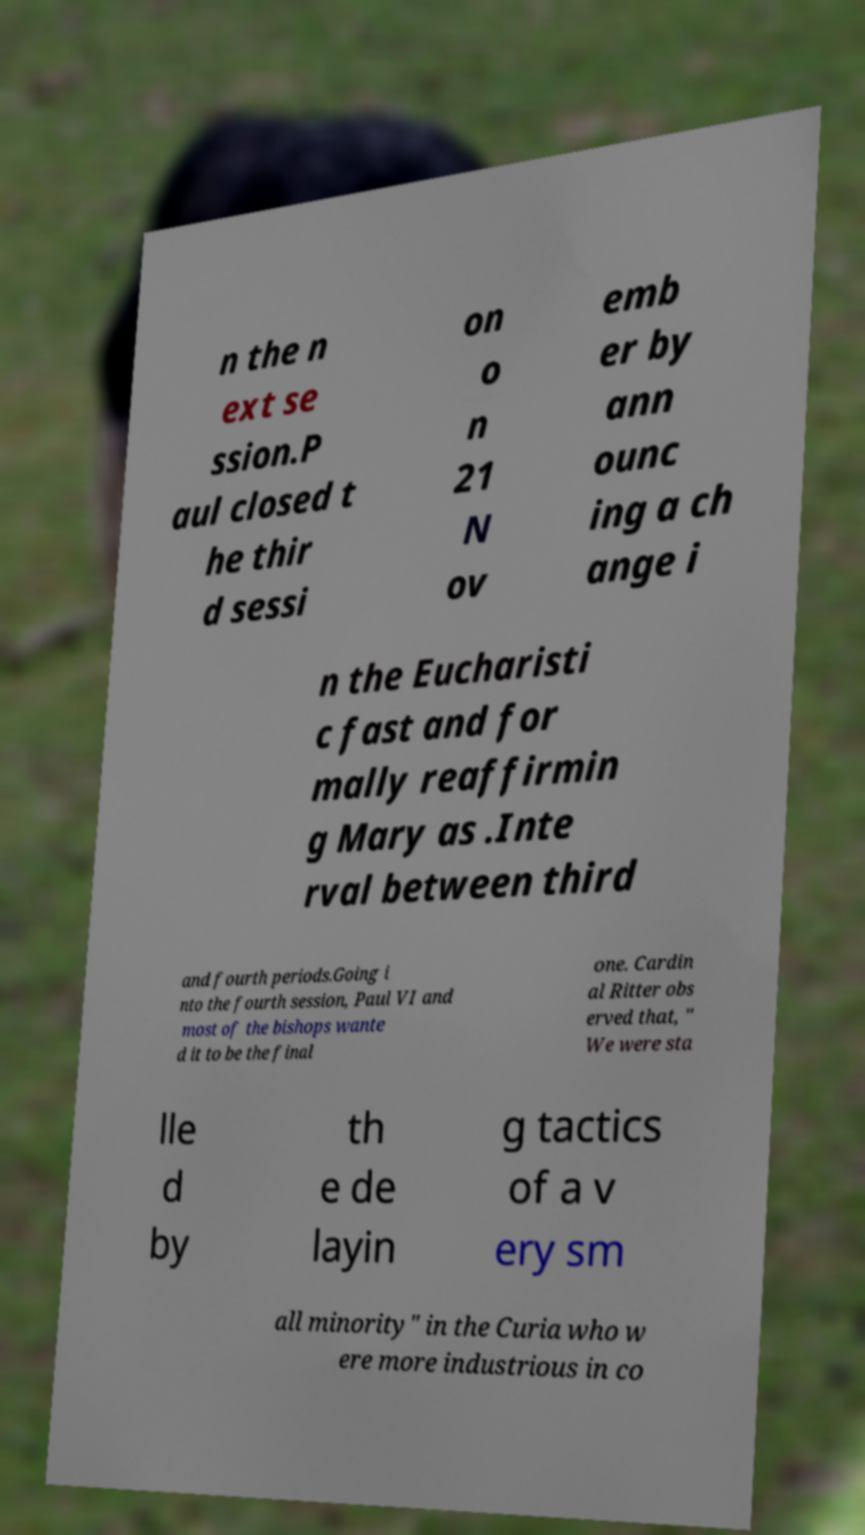There's text embedded in this image that I need extracted. Can you transcribe it verbatim? n the n ext se ssion.P aul closed t he thir d sessi on o n 21 N ov emb er by ann ounc ing a ch ange i n the Eucharisti c fast and for mally reaffirmin g Mary as .Inte rval between third and fourth periods.Going i nto the fourth session, Paul VI and most of the bishops wante d it to be the final one. Cardin al Ritter obs erved that, " We were sta lle d by th e de layin g tactics of a v ery sm all minority" in the Curia who w ere more industrious in co 